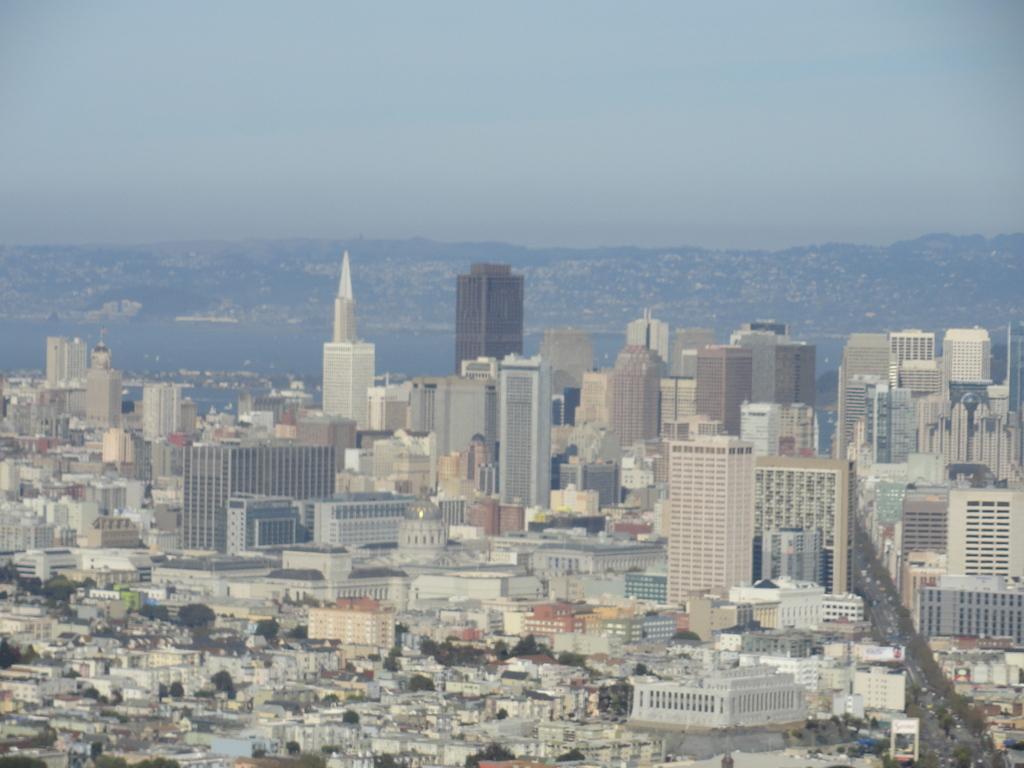How would you summarize this image in a sentence or two? In this image we can see buildings, road, vehicles on the road. In the background of the image there are mountains, sky and water. 